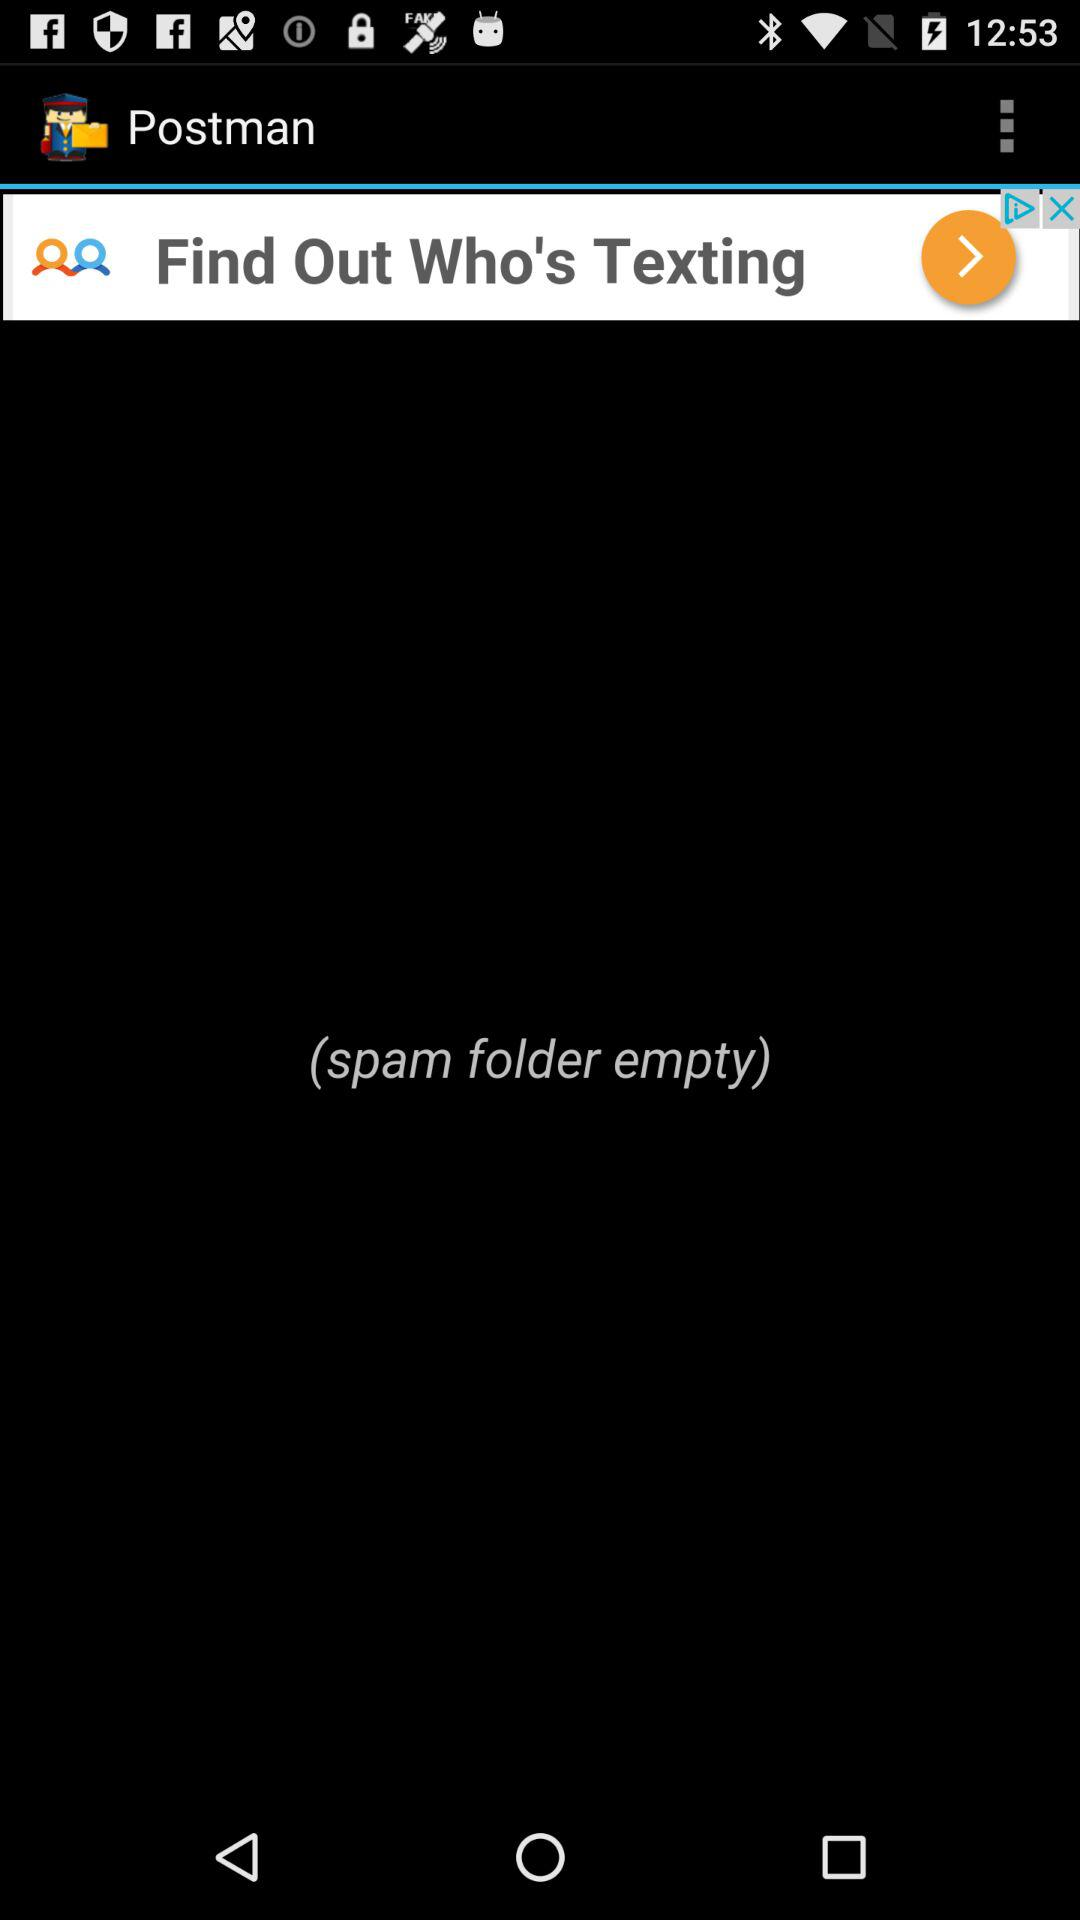What is the name of the application? The name of the application is "Postman". 